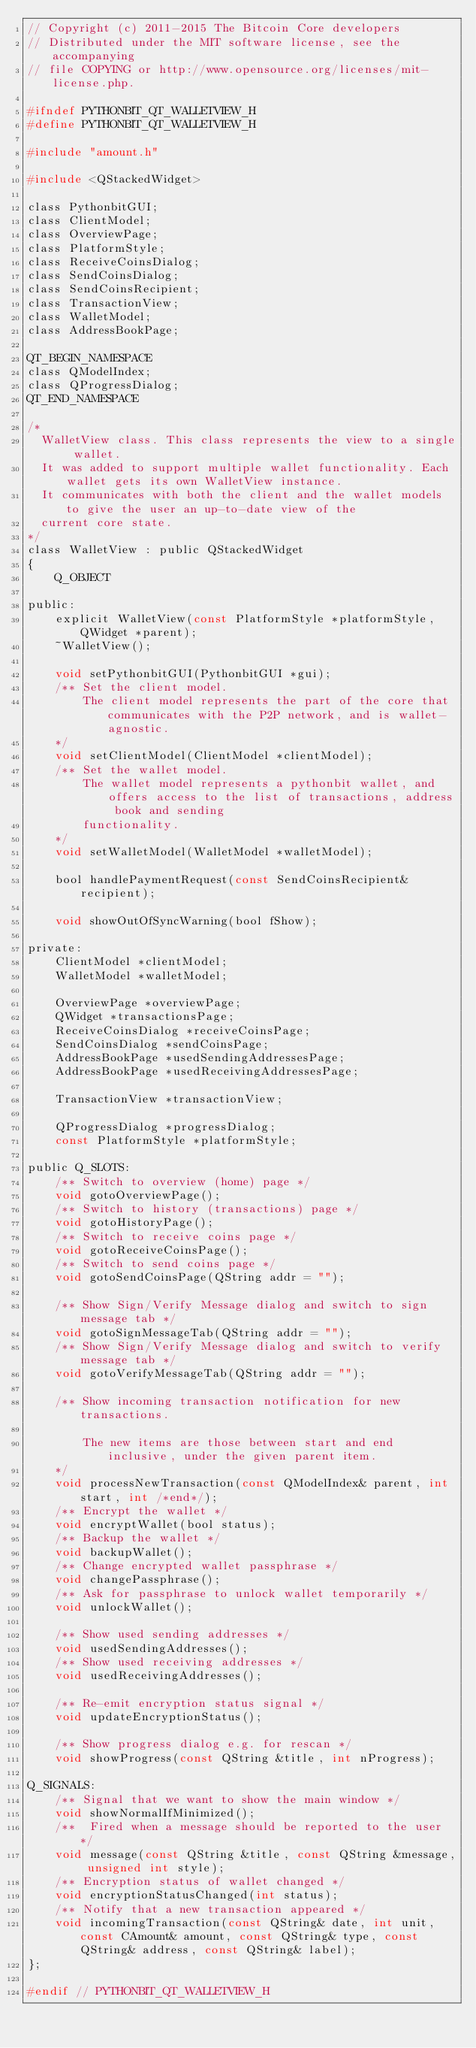Convert code to text. <code><loc_0><loc_0><loc_500><loc_500><_C_>// Copyright (c) 2011-2015 The Bitcoin Core developers
// Distributed under the MIT software license, see the accompanying
// file COPYING or http://www.opensource.org/licenses/mit-license.php.

#ifndef PYTHONBIT_QT_WALLETVIEW_H
#define PYTHONBIT_QT_WALLETVIEW_H

#include "amount.h"

#include <QStackedWidget>

class PythonbitGUI;
class ClientModel;
class OverviewPage;
class PlatformStyle;
class ReceiveCoinsDialog;
class SendCoinsDialog;
class SendCoinsRecipient;
class TransactionView;
class WalletModel;
class AddressBookPage;

QT_BEGIN_NAMESPACE
class QModelIndex;
class QProgressDialog;
QT_END_NAMESPACE

/*
  WalletView class. This class represents the view to a single wallet.
  It was added to support multiple wallet functionality. Each wallet gets its own WalletView instance.
  It communicates with both the client and the wallet models to give the user an up-to-date view of the
  current core state.
*/
class WalletView : public QStackedWidget
{
    Q_OBJECT

public:
    explicit WalletView(const PlatformStyle *platformStyle, QWidget *parent);
    ~WalletView();

    void setPythonbitGUI(PythonbitGUI *gui);
    /** Set the client model.
        The client model represents the part of the core that communicates with the P2P network, and is wallet-agnostic.
    */
    void setClientModel(ClientModel *clientModel);
    /** Set the wallet model.
        The wallet model represents a pythonbit wallet, and offers access to the list of transactions, address book and sending
        functionality.
    */
    void setWalletModel(WalletModel *walletModel);

    bool handlePaymentRequest(const SendCoinsRecipient& recipient);

    void showOutOfSyncWarning(bool fShow);

private:
    ClientModel *clientModel;
    WalletModel *walletModel;

    OverviewPage *overviewPage;
    QWidget *transactionsPage;
    ReceiveCoinsDialog *receiveCoinsPage;
    SendCoinsDialog *sendCoinsPage;
    AddressBookPage *usedSendingAddressesPage;
    AddressBookPage *usedReceivingAddressesPage;

    TransactionView *transactionView;

    QProgressDialog *progressDialog;
    const PlatformStyle *platformStyle;

public Q_SLOTS:
    /** Switch to overview (home) page */
    void gotoOverviewPage();
    /** Switch to history (transactions) page */
    void gotoHistoryPage();
    /** Switch to receive coins page */
    void gotoReceiveCoinsPage();
    /** Switch to send coins page */
    void gotoSendCoinsPage(QString addr = "");

    /** Show Sign/Verify Message dialog and switch to sign message tab */
    void gotoSignMessageTab(QString addr = "");
    /** Show Sign/Verify Message dialog and switch to verify message tab */
    void gotoVerifyMessageTab(QString addr = "");

    /** Show incoming transaction notification for new transactions.

        The new items are those between start and end inclusive, under the given parent item.
    */
    void processNewTransaction(const QModelIndex& parent, int start, int /*end*/);
    /** Encrypt the wallet */
    void encryptWallet(bool status);
    /** Backup the wallet */
    void backupWallet();
    /** Change encrypted wallet passphrase */
    void changePassphrase();
    /** Ask for passphrase to unlock wallet temporarily */
    void unlockWallet();

    /** Show used sending addresses */
    void usedSendingAddresses();
    /** Show used receiving addresses */
    void usedReceivingAddresses();

    /** Re-emit encryption status signal */
    void updateEncryptionStatus();

    /** Show progress dialog e.g. for rescan */
    void showProgress(const QString &title, int nProgress);

Q_SIGNALS:
    /** Signal that we want to show the main window */
    void showNormalIfMinimized();
    /**  Fired when a message should be reported to the user */
    void message(const QString &title, const QString &message, unsigned int style);
    /** Encryption status of wallet changed */
    void encryptionStatusChanged(int status);
    /** Notify that a new transaction appeared */
    void incomingTransaction(const QString& date, int unit, const CAmount& amount, const QString& type, const QString& address, const QString& label);
};

#endif // PYTHONBIT_QT_WALLETVIEW_H
</code> 